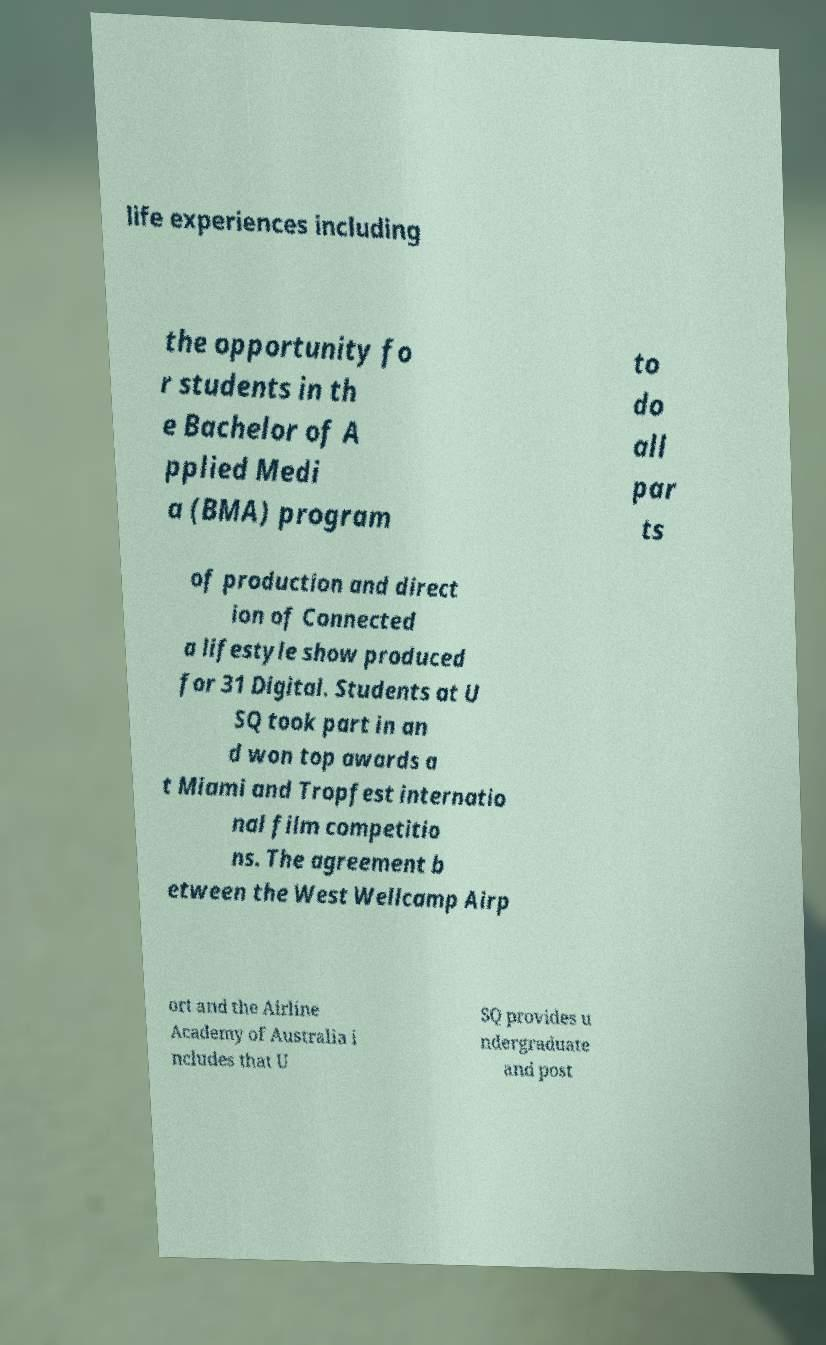Can you accurately transcribe the text from the provided image for me? life experiences including the opportunity fo r students in th e Bachelor of A pplied Medi a (BMA) program to do all par ts of production and direct ion of Connected a lifestyle show produced for 31 Digital. Students at U SQ took part in an d won top awards a t Miami and Tropfest internatio nal film competitio ns. The agreement b etween the West Wellcamp Airp ort and the Airline Academy of Australia i ncludes that U SQ provides u ndergraduate and post 